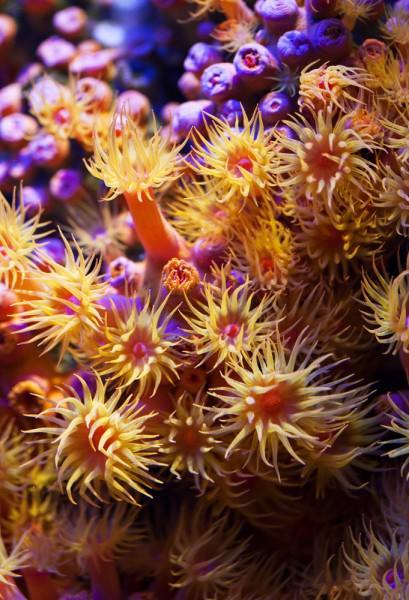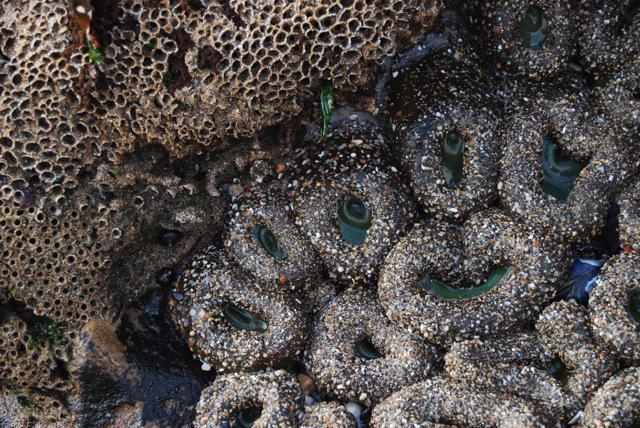The first image is the image on the left, the second image is the image on the right. Analyze the images presented: Is the assertion "The left image includes at least eight yellowish anemone that resemble flowers." valid? Answer yes or no. Yes. The first image is the image on the left, the second image is the image on the right. Analyze the images presented: Is the assertion "In at least one image there is a peach corral with no less than twenty tentacles being moved by the water." valid? Answer yes or no. No. 